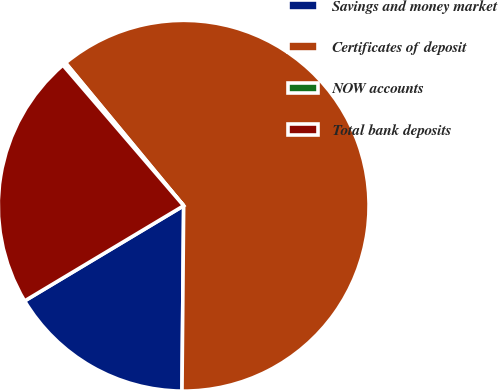Convert chart. <chart><loc_0><loc_0><loc_500><loc_500><pie_chart><fcel>Savings and money market<fcel>Certificates of deposit<fcel>NOW accounts<fcel>Total bank deposits<nl><fcel>16.27%<fcel>61.14%<fcel>0.3%<fcel>22.29%<nl></chart> 